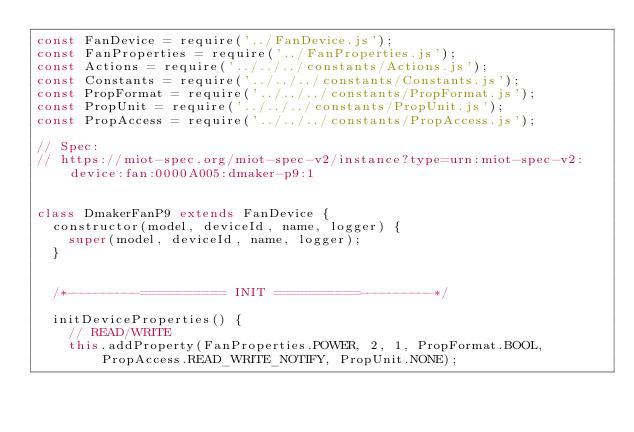Convert code to text. <code><loc_0><loc_0><loc_500><loc_500><_JavaScript_>const FanDevice = require('../FanDevice.js');
const FanProperties = require('../FanProperties.js');
const Actions = require('../../../constants/Actions.js');
const Constants = require('../../../constants/Constants.js');
const PropFormat = require('../../../constants/PropFormat.js');
const PropUnit = require('../../../constants/PropUnit.js');
const PropAccess = require('../../../constants/PropAccess.js');

// Spec:
// https://miot-spec.org/miot-spec-v2/instance?type=urn:miot-spec-v2:device:fan:0000A005:dmaker-p9:1


class DmakerFanP9 extends FanDevice {
  constructor(model, deviceId, name, logger) {
    super(model, deviceId, name, logger);
  }


  /*----------========== INIT ==========----------*/

  initDeviceProperties() {
    // READ/WRITE
    this.addProperty(FanProperties.POWER, 2, 1, PropFormat.BOOL, PropAccess.READ_WRITE_NOTIFY, PropUnit.NONE);</code> 